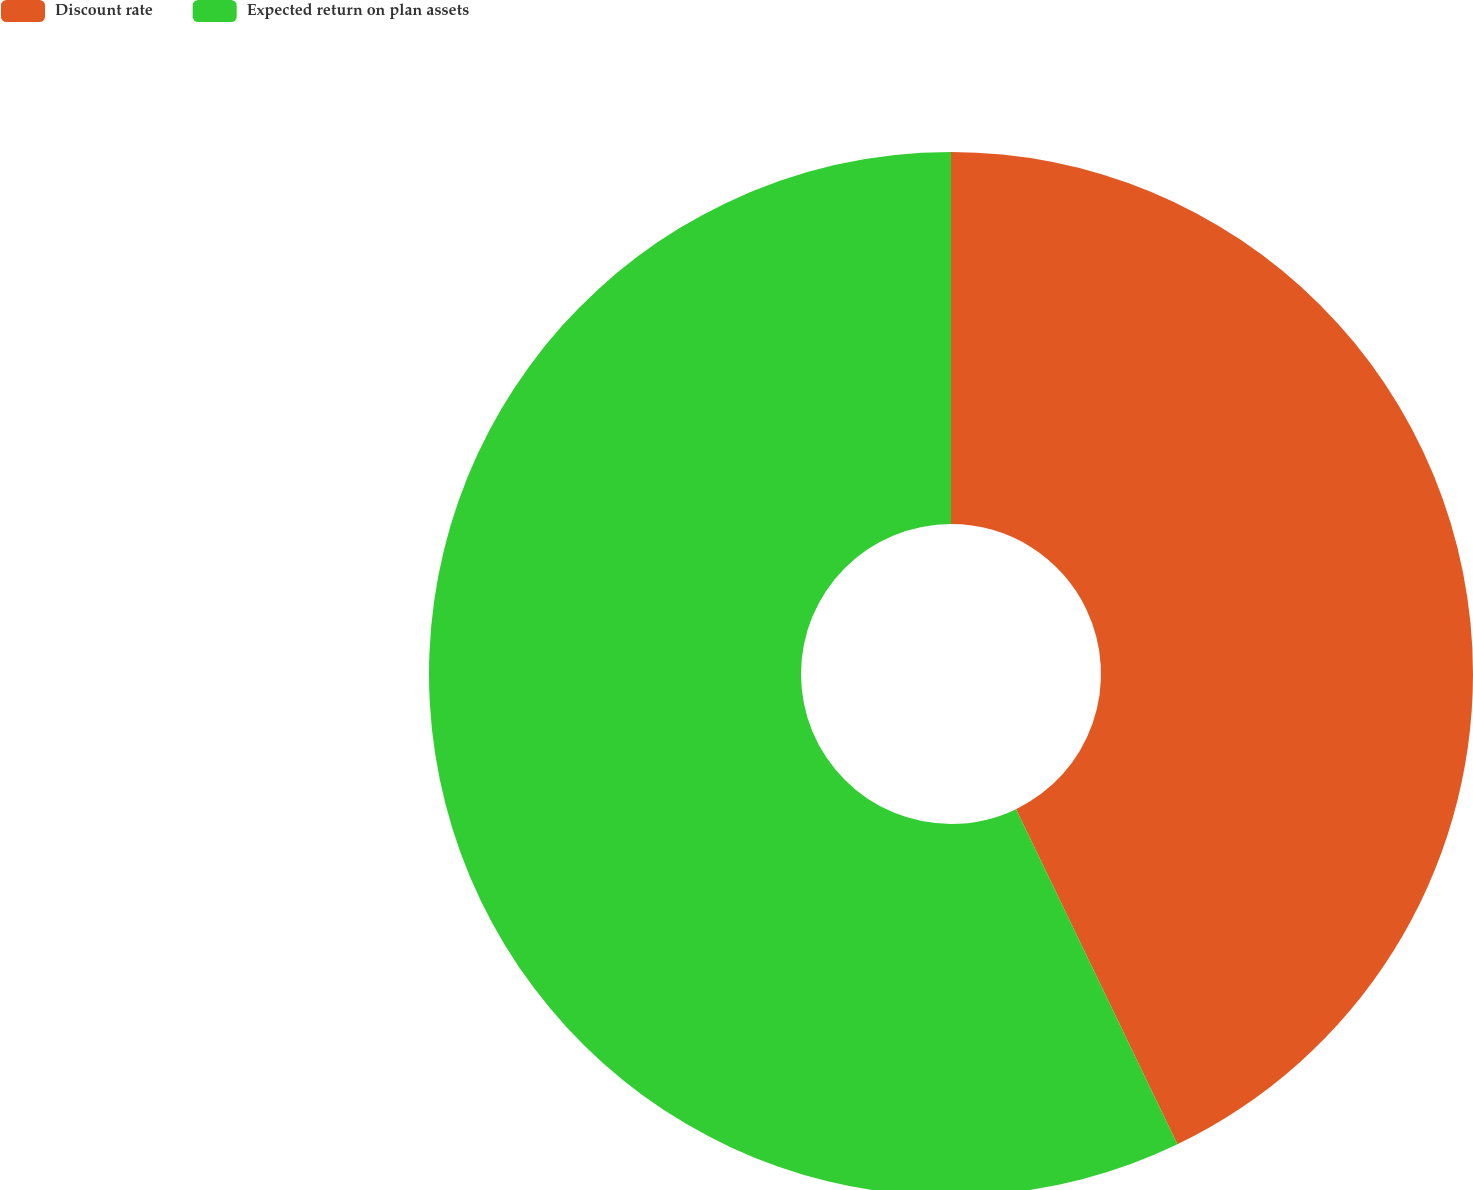Convert chart to OTSL. <chart><loc_0><loc_0><loc_500><loc_500><pie_chart><fcel>Discount rate<fcel>Expected return on plan assets<nl><fcel>42.86%<fcel>57.14%<nl></chart> 